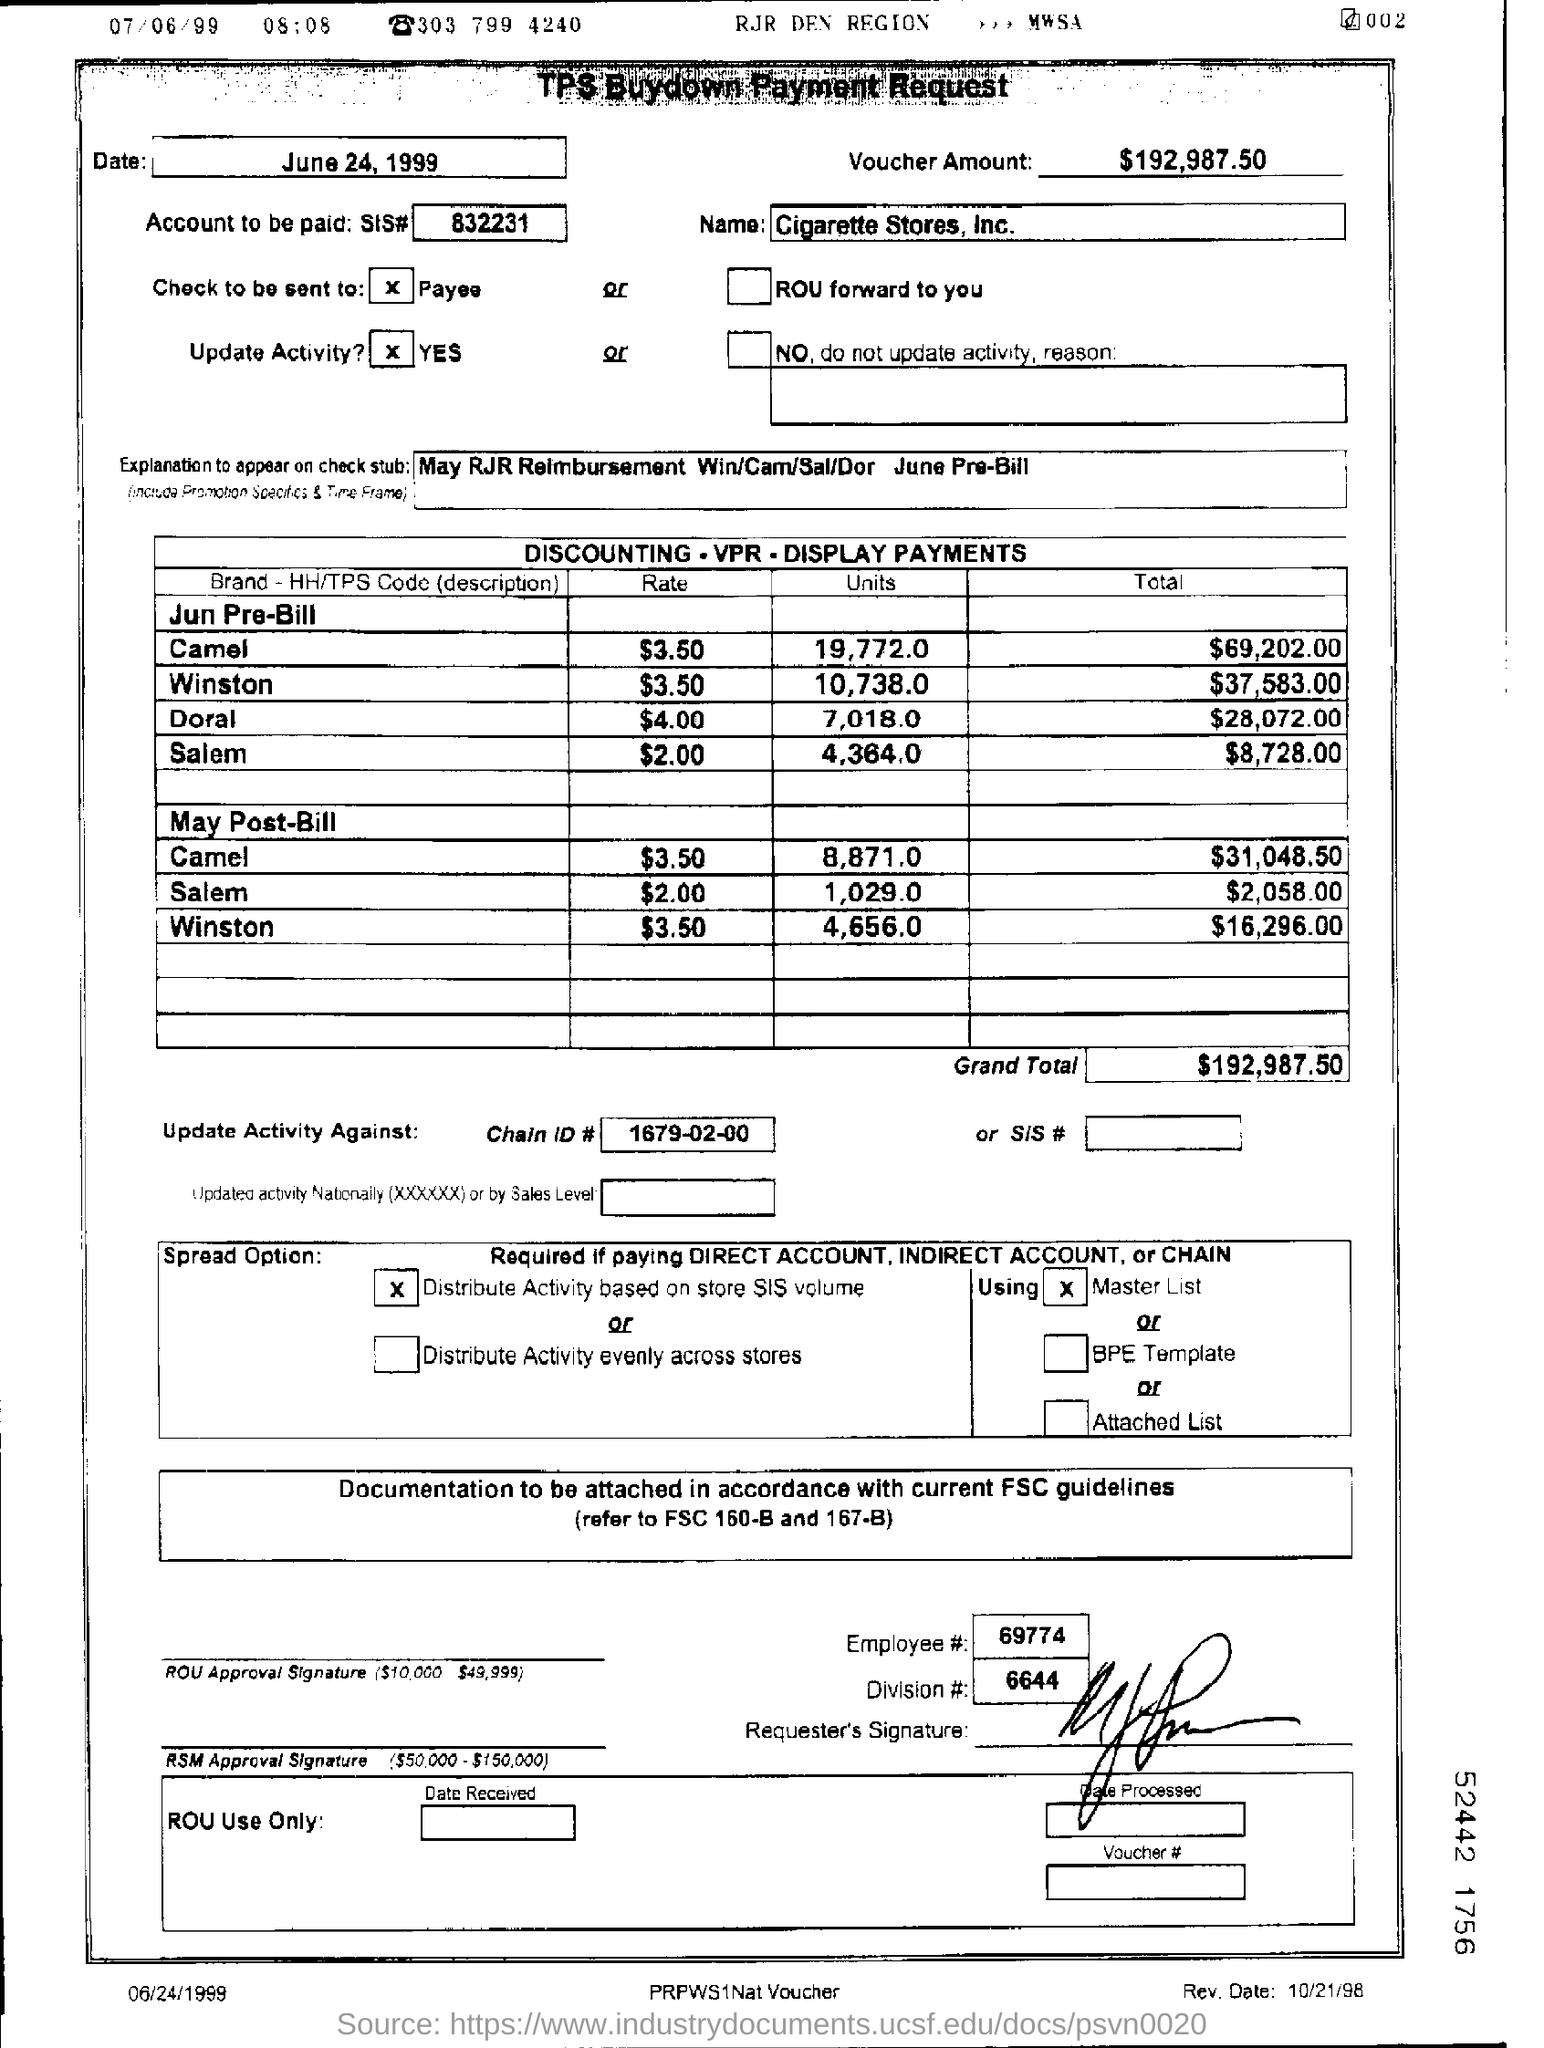Give the division # of the requester?
Give a very brief answer. 6644. What is the "Date" written on the top left box?
Offer a terse response. June 24, 1999. What is the name?
Ensure brevity in your answer.  Cigarette stores , inc. What is the grand total?
Provide a short and direct response. $192,987.50. What is the chain ID?
Your answer should be compact. 1679-02-00. 